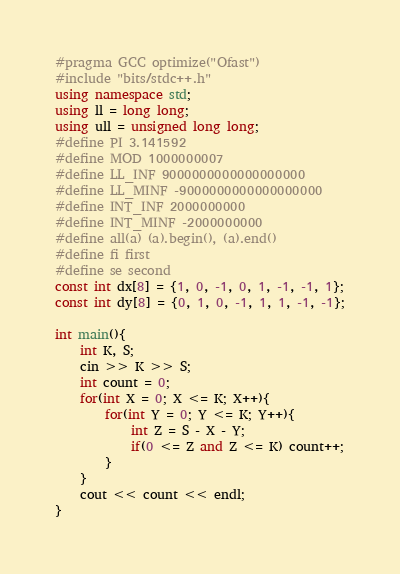<code> <loc_0><loc_0><loc_500><loc_500><_C++_>#pragma GCC optimize("Ofast")
#include "bits/stdc++.h"
using namespace std;
using ll = long long;
using ull = unsigned long long;
#define PI 3.141592
#define MOD 1000000007
#define LL_INF 9000000000000000000
#define LL_MINF -9000000000000000000
#define INT_INF 2000000000
#define INT_MINF -2000000000
#define all(a) (a).begin(), (a).end()
#define fi first
#define se second
const int dx[8] = {1, 0, -1, 0, 1, -1, -1, 1};
const int dy[8] = {0, 1, 0, -1, 1, 1, -1, -1};

int main(){
    int K, S;
    cin >> K >> S;
    int count = 0;
    for(int X = 0; X <= K; X++){
        for(int Y = 0; Y <= K; Y++){
            int Z = S - X - Y;
            if(0 <= Z and Z <= K) count++;
        }
    }
    cout << count << endl;
}
</code> 